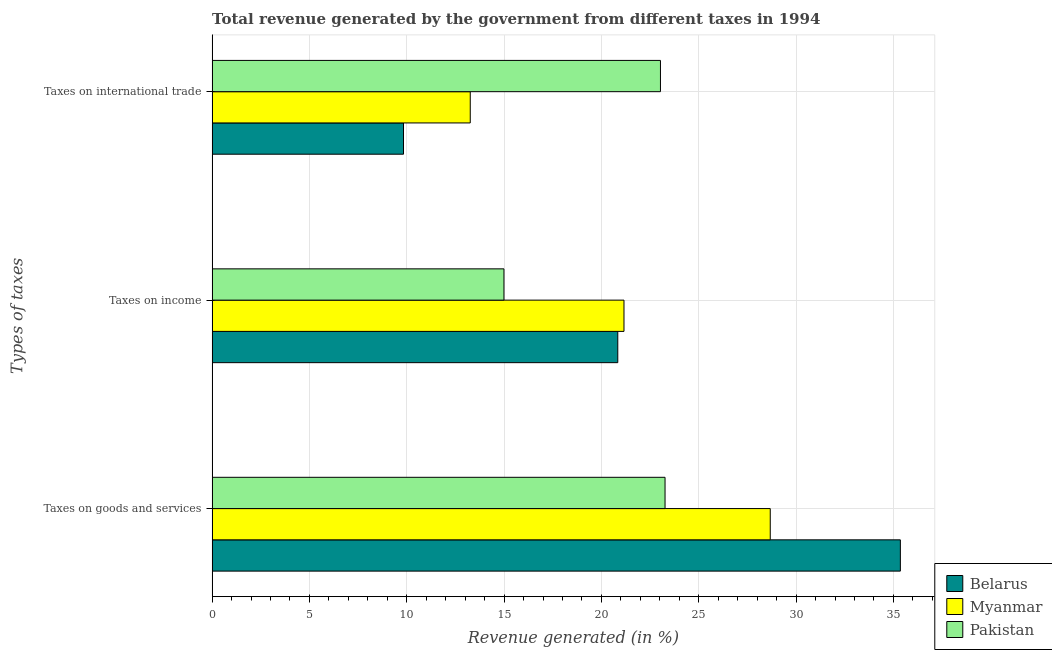How many different coloured bars are there?
Your response must be concise. 3. Are the number of bars per tick equal to the number of legend labels?
Keep it short and to the point. Yes. How many bars are there on the 1st tick from the bottom?
Provide a succinct answer. 3. What is the label of the 3rd group of bars from the top?
Offer a very short reply. Taxes on goods and services. What is the percentage of revenue generated by taxes on income in Myanmar?
Give a very brief answer. 21.16. Across all countries, what is the maximum percentage of revenue generated by taxes on goods and services?
Keep it short and to the point. 35.36. Across all countries, what is the minimum percentage of revenue generated by taxes on goods and services?
Your answer should be very brief. 23.27. In which country was the percentage of revenue generated by taxes on goods and services maximum?
Your answer should be compact. Belarus. What is the total percentage of revenue generated by taxes on goods and services in the graph?
Ensure brevity in your answer.  87.3. What is the difference between the percentage of revenue generated by taxes on goods and services in Pakistan and that in Myanmar?
Make the answer very short. -5.4. What is the difference between the percentage of revenue generated by taxes on goods and services in Pakistan and the percentage of revenue generated by taxes on income in Belarus?
Provide a short and direct response. 2.43. What is the average percentage of revenue generated by taxes on goods and services per country?
Ensure brevity in your answer.  29.1. What is the difference between the percentage of revenue generated by taxes on income and percentage of revenue generated by tax on international trade in Pakistan?
Offer a very short reply. -8.04. What is the ratio of the percentage of revenue generated by tax on international trade in Myanmar to that in Pakistan?
Your answer should be compact. 0.58. Is the percentage of revenue generated by taxes on goods and services in Pakistan less than that in Belarus?
Provide a succinct answer. Yes. Is the difference between the percentage of revenue generated by tax on international trade in Myanmar and Pakistan greater than the difference between the percentage of revenue generated by taxes on income in Myanmar and Pakistan?
Offer a terse response. No. What is the difference between the highest and the second highest percentage of revenue generated by taxes on goods and services?
Your answer should be very brief. 6.68. What is the difference between the highest and the lowest percentage of revenue generated by tax on international trade?
Provide a short and direct response. 13.2. In how many countries, is the percentage of revenue generated by taxes on income greater than the average percentage of revenue generated by taxes on income taken over all countries?
Give a very brief answer. 2. What does the 3rd bar from the top in Taxes on goods and services represents?
Give a very brief answer. Belarus. How many countries are there in the graph?
Offer a terse response. 3. Are the values on the major ticks of X-axis written in scientific E-notation?
Ensure brevity in your answer.  No. Does the graph contain grids?
Offer a terse response. Yes. How are the legend labels stacked?
Your answer should be very brief. Vertical. What is the title of the graph?
Your answer should be compact. Total revenue generated by the government from different taxes in 1994. What is the label or title of the X-axis?
Offer a terse response. Revenue generated (in %). What is the label or title of the Y-axis?
Provide a succinct answer. Types of taxes. What is the Revenue generated (in %) of Belarus in Taxes on goods and services?
Provide a short and direct response. 35.36. What is the Revenue generated (in %) in Myanmar in Taxes on goods and services?
Your answer should be very brief. 28.67. What is the Revenue generated (in %) of Pakistan in Taxes on goods and services?
Ensure brevity in your answer.  23.27. What is the Revenue generated (in %) in Belarus in Taxes on income?
Give a very brief answer. 20.84. What is the Revenue generated (in %) in Myanmar in Taxes on income?
Offer a terse response. 21.16. What is the Revenue generated (in %) of Pakistan in Taxes on income?
Provide a succinct answer. 14.99. What is the Revenue generated (in %) in Belarus in Taxes on international trade?
Provide a succinct answer. 9.83. What is the Revenue generated (in %) of Myanmar in Taxes on international trade?
Your response must be concise. 13.26. What is the Revenue generated (in %) of Pakistan in Taxes on international trade?
Give a very brief answer. 23.03. Across all Types of taxes, what is the maximum Revenue generated (in %) of Belarus?
Keep it short and to the point. 35.36. Across all Types of taxes, what is the maximum Revenue generated (in %) of Myanmar?
Your answer should be compact. 28.67. Across all Types of taxes, what is the maximum Revenue generated (in %) in Pakistan?
Make the answer very short. 23.27. Across all Types of taxes, what is the minimum Revenue generated (in %) in Belarus?
Your answer should be compact. 9.83. Across all Types of taxes, what is the minimum Revenue generated (in %) in Myanmar?
Keep it short and to the point. 13.26. Across all Types of taxes, what is the minimum Revenue generated (in %) in Pakistan?
Give a very brief answer. 14.99. What is the total Revenue generated (in %) in Belarus in the graph?
Your answer should be very brief. 66.03. What is the total Revenue generated (in %) of Myanmar in the graph?
Keep it short and to the point. 63.09. What is the total Revenue generated (in %) of Pakistan in the graph?
Ensure brevity in your answer.  61.29. What is the difference between the Revenue generated (in %) of Belarus in Taxes on goods and services and that in Taxes on income?
Your response must be concise. 14.52. What is the difference between the Revenue generated (in %) of Myanmar in Taxes on goods and services and that in Taxes on income?
Ensure brevity in your answer.  7.51. What is the difference between the Revenue generated (in %) of Pakistan in Taxes on goods and services and that in Taxes on income?
Your answer should be very brief. 8.28. What is the difference between the Revenue generated (in %) of Belarus in Taxes on goods and services and that in Taxes on international trade?
Offer a terse response. 25.53. What is the difference between the Revenue generated (in %) in Myanmar in Taxes on goods and services and that in Taxes on international trade?
Your answer should be very brief. 15.41. What is the difference between the Revenue generated (in %) in Pakistan in Taxes on goods and services and that in Taxes on international trade?
Provide a succinct answer. 0.24. What is the difference between the Revenue generated (in %) in Belarus in Taxes on income and that in Taxes on international trade?
Your answer should be compact. 11.01. What is the difference between the Revenue generated (in %) of Myanmar in Taxes on income and that in Taxes on international trade?
Make the answer very short. 7.9. What is the difference between the Revenue generated (in %) of Pakistan in Taxes on income and that in Taxes on international trade?
Keep it short and to the point. -8.04. What is the difference between the Revenue generated (in %) of Belarus in Taxes on goods and services and the Revenue generated (in %) of Myanmar in Taxes on income?
Provide a succinct answer. 14.2. What is the difference between the Revenue generated (in %) in Belarus in Taxes on goods and services and the Revenue generated (in %) in Pakistan in Taxes on income?
Your answer should be very brief. 20.37. What is the difference between the Revenue generated (in %) of Myanmar in Taxes on goods and services and the Revenue generated (in %) of Pakistan in Taxes on income?
Ensure brevity in your answer.  13.68. What is the difference between the Revenue generated (in %) in Belarus in Taxes on goods and services and the Revenue generated (in %) in Myanmar in Taxes on international trade?
Offer a terse response. 22.1. What is the difference between the Revenue generated (in %) in Belarus in Taxes on goods and services and the Revenue generated (in %) in Pakistan in Taxes on international trade?
Provide a short and direct response. 12.32. What is the difference between the Revenue generated (in %) in Myanmar in Taxes on goods and services and the Revenue generated (in %) in Pakistan in Taxes on international trade?
Keep it short and to the point. 5.64. What is the difference between the Revenue generated (in %) in Belarus in Taxes on income and the Revenue generated (in %) in Myanmar in Taxes on international trade?
Provide a succinct answer. 7.58. What is the difference between the Revenue generated (in %) of Belarus in Taxes on income and the Revenue generated (in %) of Pakistan in Taxes on international trade?
Ensure brevity in your answer.  -2.19. What is the difference between the Revenue generated (in %) in Myanmar in Taxes on income and the Revenue generated (in %) in Pakistan in Taxes on international trade?
Provide a succinct answer. -1.87. What is the average Revenue generated (in %) in Belarus per Types of taxes?
Ensure brevity in your answer.  22.01. What is the average Revenue generated (in %) of Myanmar per Types of taxes?
Your response must be concise. 21.03. What is the average Revenue generated (in %) of Pakistan per Types of taxes?
Keep it short and to the point. 20.43. What is the difference between the Revenue generated (in %) in Belarus and Revenue generated (in %) in Myanmar in Taxes on goods and services?
Provide a succinct answer. 6.68. What is the difference between the Revenue generated (in %) of Belarus and Revenue generated (in %) of Pakistan in Taxes on goods and services?
Ensure brevity in your answer.  12.09. What is the difference between the Revenue generated (in %) of Myanmar and Revenue generated (in %) of Pakistan in Taxes on goods and services?
Offer a very short reply. 5.4. What is the difference between the Revenue generated (in %) in Belarus and Revenue generated (in %) in Myanmar in Taxes on income?
Give a very brief answer. -0.32. What is the difference between the Revenue generated (in %) in Belarus and Revenue generated (in %) in Pakistan in Taxes on income?
Give a very brief answer. 5.85. What is the difference between the Revenue generated (in %) of Myanmar and Revenue generated (in %) of Pakistan in Taxes on income?
Your response must be concise. 6.17. What is the difference between the Revenue generated (in %) in Belarus and Revenue generated (in %) in Myanmar in Taxes on international trade?
Keep it short and to the point. -3.43. What is the difference between the Revenue generated (in %) in Belarus and Revenue generated (in %) in Pakistan in Taxes on international trade?
Ensure brevity in your answer.  -13.2. What is the difference between the Revenue generated (in %) in Myanmar and Revenue generated (in %) in Pakistan in Taxes on international trade?
Give a very brief answer. -9.77. What is the ratio of the Revenue generated (in %) in Belarus in Taxes on goods and services to that in Taxes on income?
Offer a very short reply. 1.7. What is the ratio of the Revenue generated (in %) of Myanmar in Taxes on goods and services to that in Taxes on income?
Make the answer very short. 1.36. What is the ratio of the Revenue generated (in %) in Pakistan in Taxes on goods and services to that in Taxes on income?
Provide a succinct answer. 1.55. What is the ratio of the Revenue generated (in %) of Belarus in Taxes on goods and services to that in Taxes on international trade?
Give a very brief answer. 3.6. What is the ratio of the Revenue generated (in %) in Myanmar in Taxes on goods and services to that in Taxes on international trade?
Ensure brevity in your answer.  2.16. What is the ratio of the Revenue generated (in %) of Pakistan in Taxes on goods and services to that in Taxes on international trade?
Make the answer very short. 1.01. What is the ratio of the Revenue generated (in %) of Belarus in Taxes on income to that in Taxes on international trade?
Give a very brief answer. 2.12. What is the ratio of the Revenue generated (in %) of Myanmar in Taxes on income to that in Taxes on international trade?
Offer a terse response. 1.6. What is the ratio of the Revenue generated (in %) of Pakistan in Taxes on income to that in Taxes on international trade?
Your response must be concise. 0.65. What is the difference between the highest and the second highest Revenue generated (in %) in Belarus?
Offer a terse response. 14.52. What is the difference between the highest and the second highest Revenue generated (in %) of Myanmar?
Your response must be concise. 7.51. What is the difference between the highest and the second highest Revenue generated (in %) in Pakistan?
Provide a short and direct response. 0.24. What is the difference between the highest and the lowest Revenue generated (in %) of Belarus?
Offer a very short reply. 25.53. What is the difference between the highest and the lowest Revenue generated (in %) of Myanmar?
Offer a very short reply. 15.41. What is the difference between the highest and the lowest Revenue generated (in %) of Pakistan?
Make the answer very short. 8.28. 